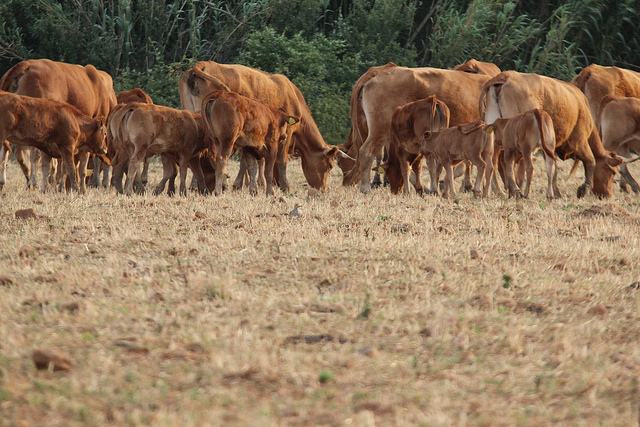Can you describe the scene in detail with imaginative storytelling? In the golden hues of late afternoon, under the vast expanse of the sky, a serene tableau unfolds. The field, covered in sun-kissed, straw-like grass, sprawls out like a rustic quilt. Scattered across this landscape are the gentle, tawny figures of cows that graze quietly, their heads bowed as they pull tender shoots from the earth. On the left, a small cluster of cows enjoys each other's company, their bodies creating soft, comforting shadows on the ground. One, with a slight sense of wanderlust, strays close to the frame's edge, almost as if beckoning the viewer into their world. Centrally located, the cows are spaced with natural precision, their different positions adding a dynamic depth to the panorama. On the right, a congregation of these bovine beauties forms a dense mass, with a few daring the edge of the image, hinting at the untamed expanse beyond. The verdant backdrop of plants and bushes cocoons this rustic stage, offering a contrasting buffer of vibrant green against the dry browns of the field. Silence reigns, save for the occasional lowing and the soft rustle of grass beneath gentle hooves, epitomizing the essence of tranquility in nature's embrace. What if this field had a surprise hidden treasure? Imagine, beneath the aged grasses and interwoven roots of this seemingly ordinary field, there lies a forgotten treasure. Unearthed only by happenstance, the treasure chest—crafted from ancient, weathered wood and bound with rusted iron—is filled with sparkling gems and golden coins, remnants of a long-forgotten past. Generations of cows have grazed blissfully unaware over this hidden fortune, its presence adding a mysterious aura to the otherwise serene landscape. As dusk falls, the soft glow of the sunset catches something beneath one cow's curious hoof—a glint of gold beneath the earth, suggesting an adventurous tale waiting to be discovered. 